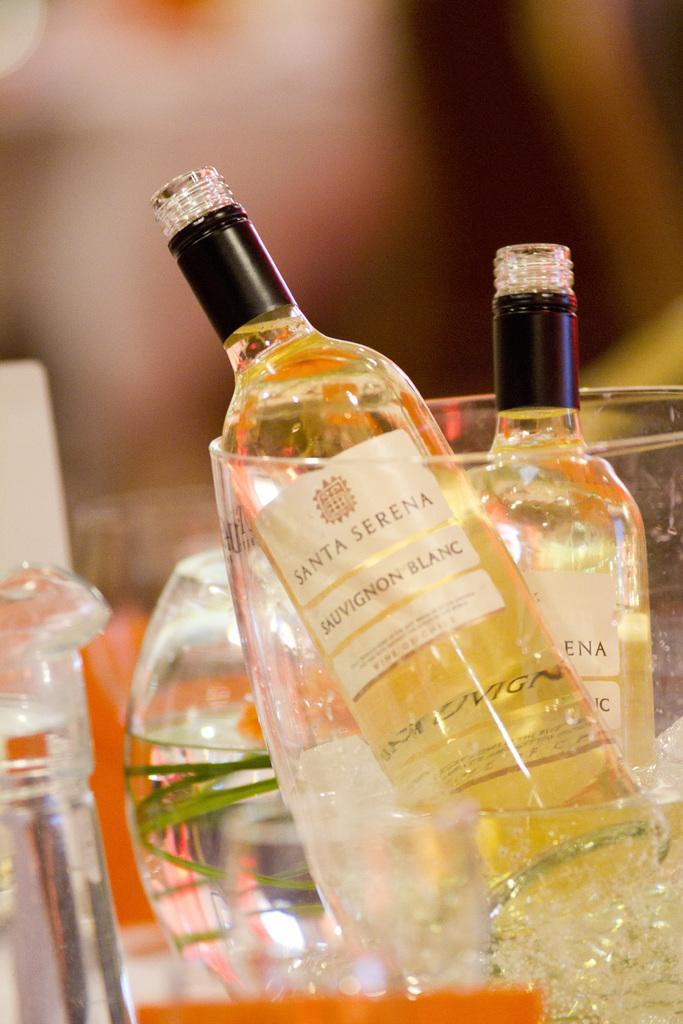Describe this image in one or two sentences. In this picture we can see bottles with stickers to it and drink in it are placed in a bucket with ice cubes and water in it and aside to this we have a jar with water and in the background it is blur. 